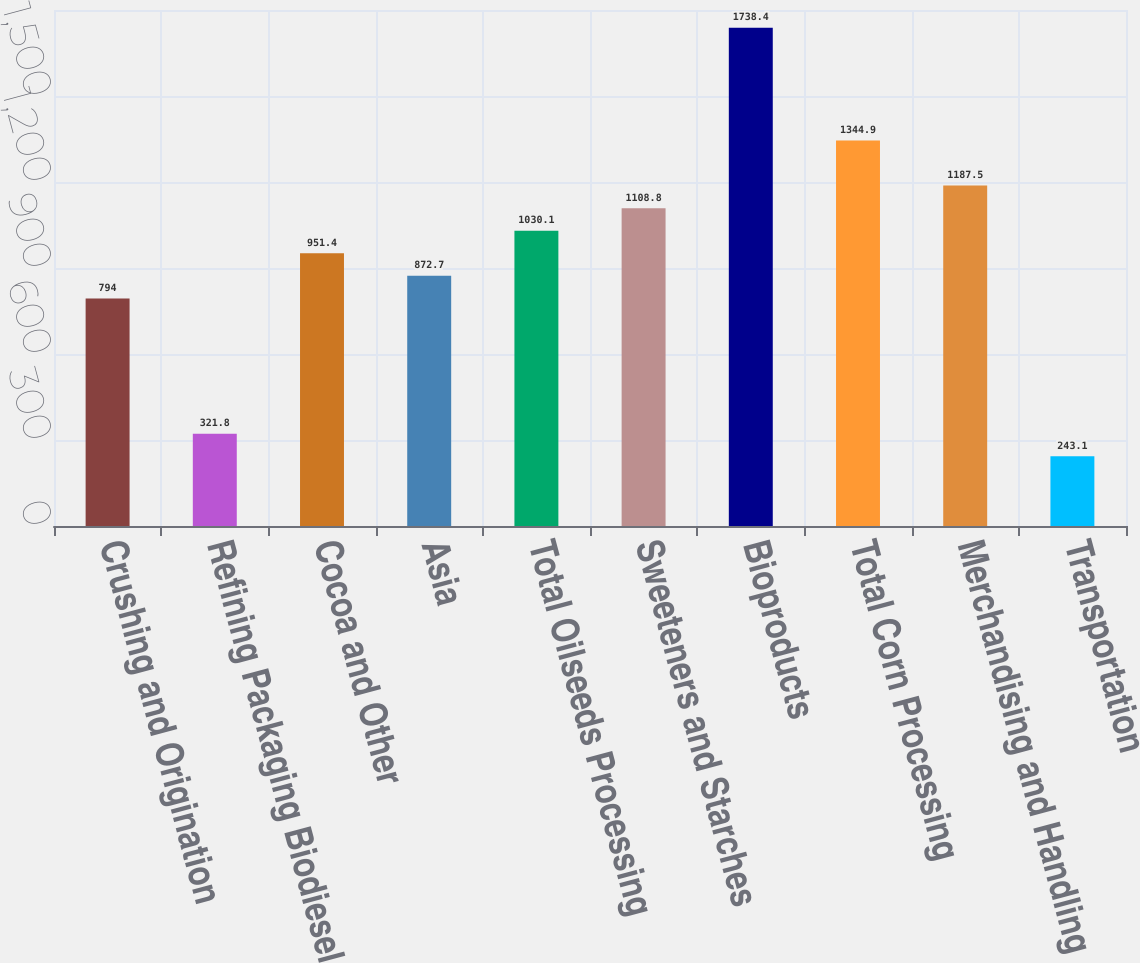<chart> <loc_0><loc_0><loc_500><loc_500><bar_chart><fcel>Crushing and Origination<fcel>Refining Packaging Biodiesel<fcel>Cocoa and Other<fcel>Asia<fcel>Total Oilseeds Processing<fcel>Sweeteners and Starches<fcel>Bioproducts<fcel>Total Corn Processing<fcel>Merchandising and Handling<fcel>Transportation<nl><fcel>794<fcel>321.8<fcel>951.4<fcel>872.7<fcel>1030.1<fcel>1108.8<fcel>1738.4<fcel>1344.9<fcel>1187.5<fcel>243.1<nl></chart> 